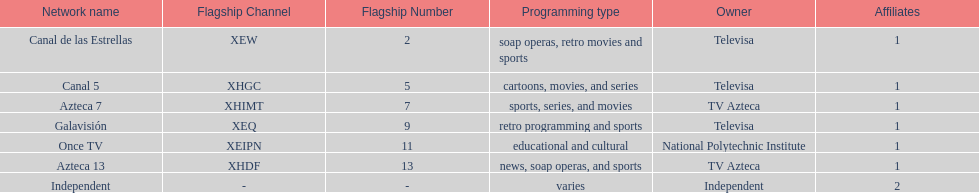How many affiliates does galavision have? 1. 